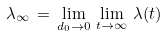Convert formula to latex. <formula><loc_0><loc_0><loc_500><loc_500>\lambda _ { \infty } \, = \, \lim _ { d _ { 0 } \to 0 } \, \lim _ { t \to \infty } \, \lambda ( t )</formula> 